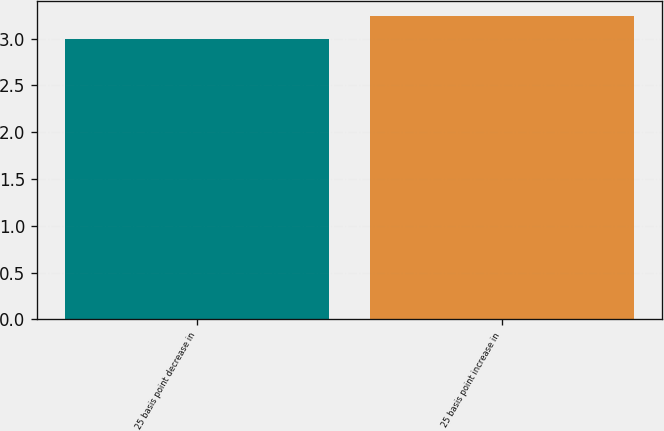Convert chart to OTSL. <chart><loc_0><loc_0><loc_500><loc_500><bar_chart><fcel>25 basis point decrease in<fcel>25 basis point increase in<nl><fcel>3<fcel>3.24<nl></chart> 